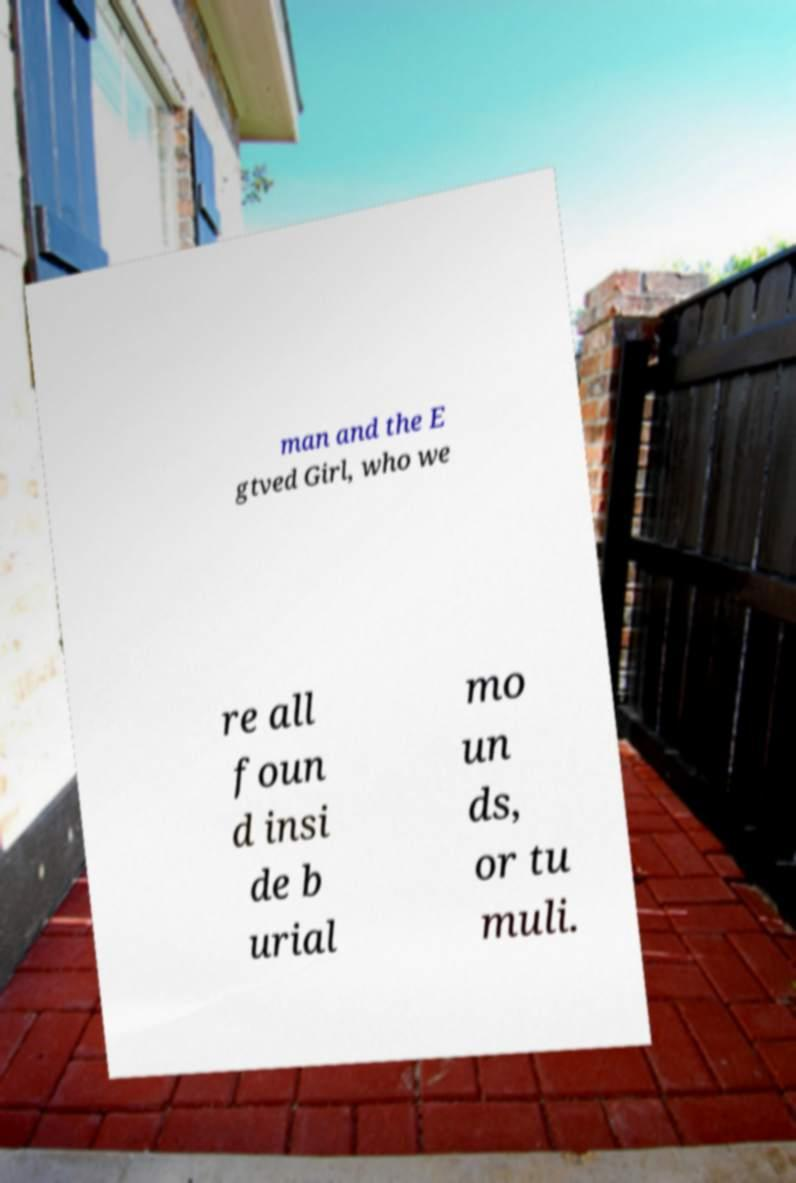Can you read and provide the text displayed in the image?This photo seems to have some interesting text. Can you extract and type it out for me? man and the E gtved Girl, who we re all foun d insi de b urial mo un ds, or tu muli. 